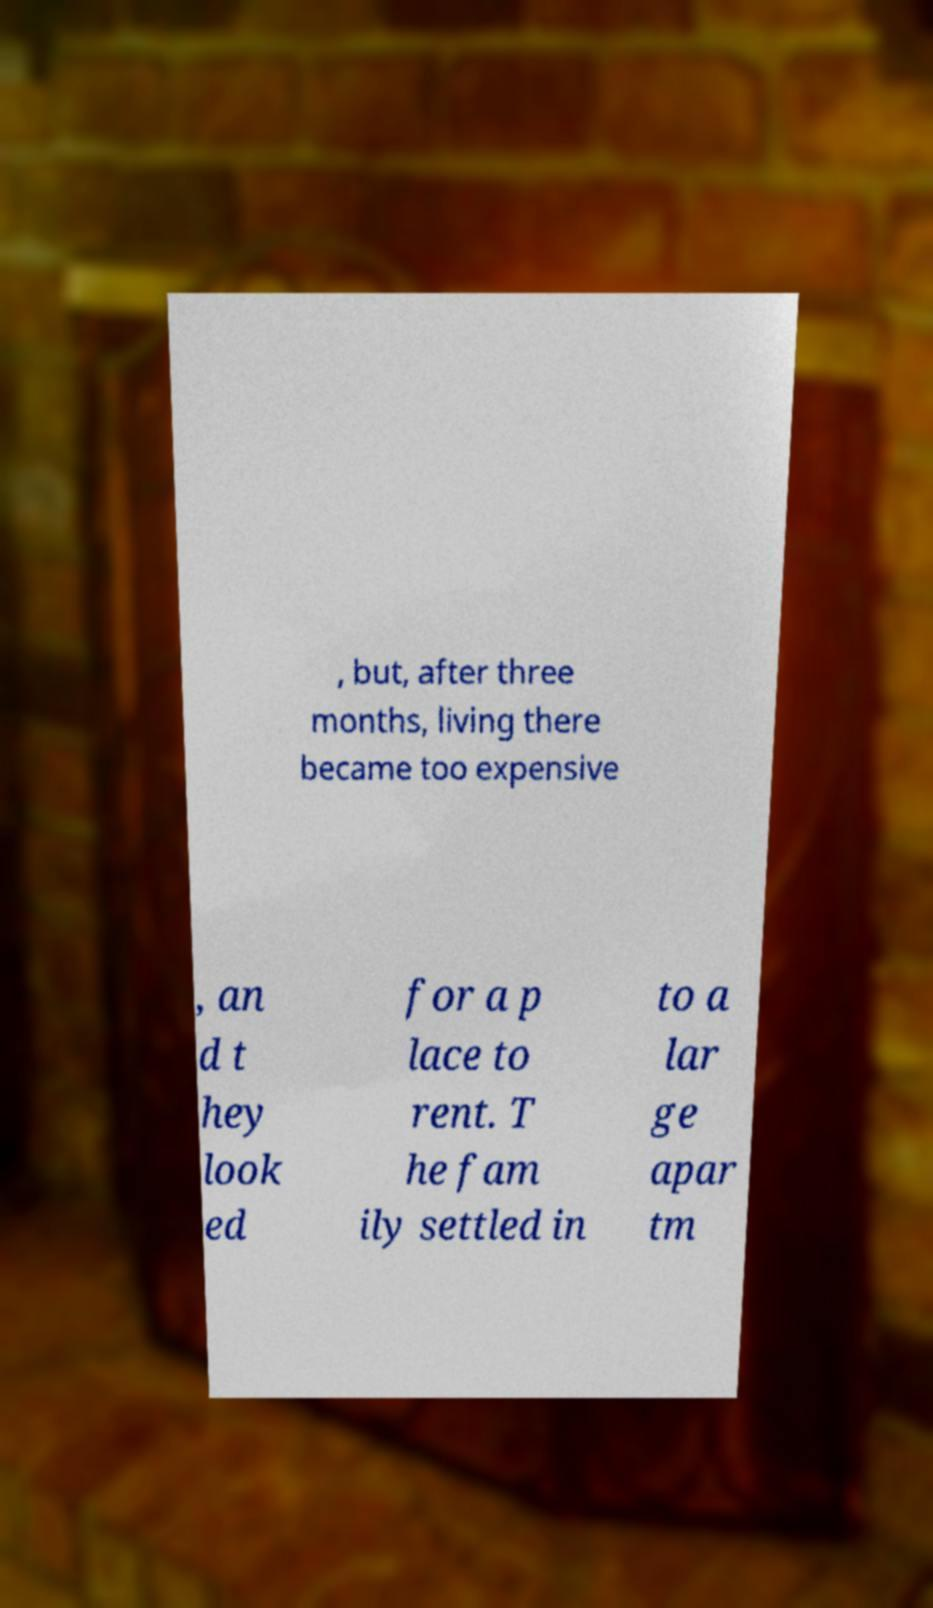Please read and relay the text visible in this image. What does it say? , but, after three months, living there became too expensive , an d t hey look ed for a p lace to rent. T he fam ily settled in to a lar ge apar tm 